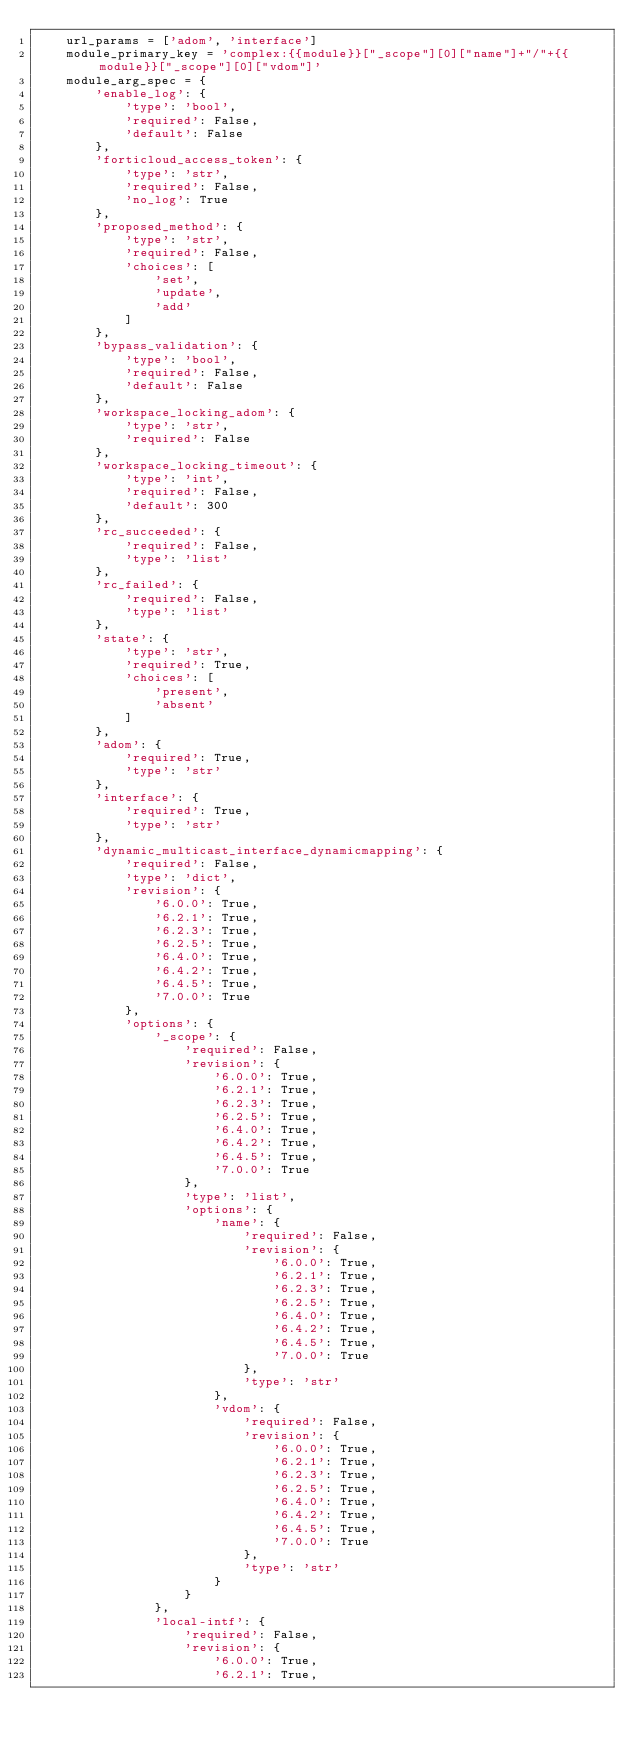Convert code to text. <code><loc_0><loc_0><loc_500><loc_500><_Python_>    url_params = ['adom', 'interface']
    module_primary_key = 'complex:{{module}}["_scope"][0]["name"]+"/"+{{module}}["_scope"][0]["vdom"]'
    module_arg_spec = {
        'enable_log': {
            'type': 'bool',
            'required': False,
            'default': False
        },
        'forticloud_access_token': {
            'type': 'str',
            'required': False,
            'no_log': True
        },
        'proposed_method': {
            'type': 'str',
            'required': False,
            'choices': [
                'set',
                'update',
                'add'
            ]
        },
        'bypass_validation': {
            'type': 'bool',
            'required': False,
            'default': False
        },
        'workspace_locking_adom': {
            'type': 'str',
            'required': False
        },
        'workspace_locking_timeout': {
            'type': 'int',
            'required': False,
            'default': 300
        },
        'rc_succeeded': {
            'required': False,
            'type': 'list'
        },
        'rc_failed': {
            'required': False,
            'type': 'list'
        },
        'state': {
            'type': 'str',
            'required': True,
            'choices': [
                'present',
                'absent'
            ]
        },
        'adom': {
            'required': True,
            'type': 'str'
        },
        'interface': {
            'required': True,
            'type': 'str'
        },
        'dynamic_multicast_interface_dynamicmapping': {
            'required': False,
            'type': 'dict',
            'revision': {
                '6.0.0': True,
                '6.2.1': True,
                '6.2.3': True,
                '6.2.5': True,
                '6.4.0': True,
                '6.4.2': True,
                '6.4.5': True,
                '7.0.0': True
            },
            'options': {
                '_scope': {
                    'required': False,
                    'revision': {
                        '6.0.0': True,
                        '6.2.1': True,
                        '6.2.3': True,
                        '6.2.5': True,
                        '6.4.0': True,
                        '6.4.2': True,
                        '6.4.5': True,
                        '7.0.0': True
                    },
                    'type': 'list',
                    'options': {
                        'name': {
                            'required': False,
                            'revision': {
                                '6.0.0': True,
                                '6.2.1': True,
                                '6.2.3': True,
                                '6.2.5': True,
                                '6.4.0': True,
                                '6.4.2': True,
                                '6.4.5': True,
                                '7.0.0': True
                            },
                            'type': 'str'
                        },
                        'vdom': {
                            'required': False,
                            'revision': {
                                '6.0.0': True,
                                '6.2.1': True,
                                '6.2.3': True,
                                '6.2.5': True,
                                '6.4.0': True,
                                '6.4.2': True,
                                '6.4.5': True,
                                '7.0.0': True
                            },
                            'type': 'str'
                        }
                    }
                },
                'local-intf': {
                    'required': False,
                    'revision': {
                        '6.0.0': True,
                        '6.2.1': True,</code> 